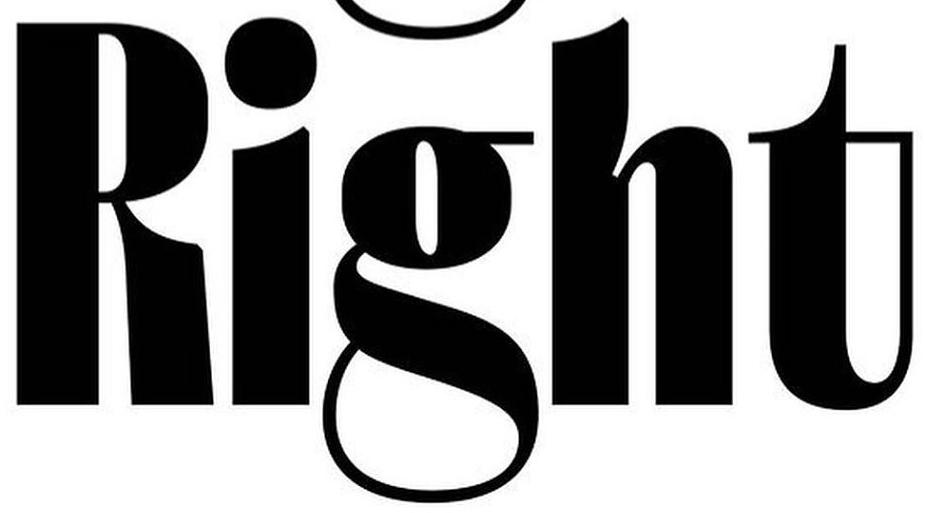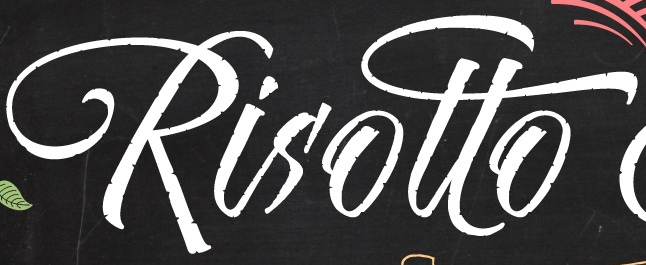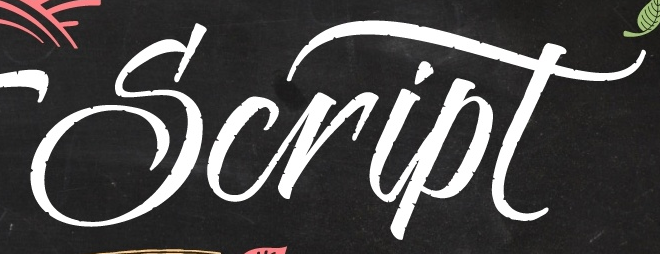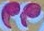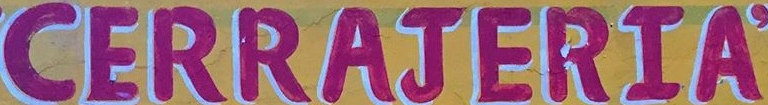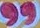What words are shown in these images in order, separated by a semicolon? Right; Risotto; Script; "; CERRAJERIA; " 